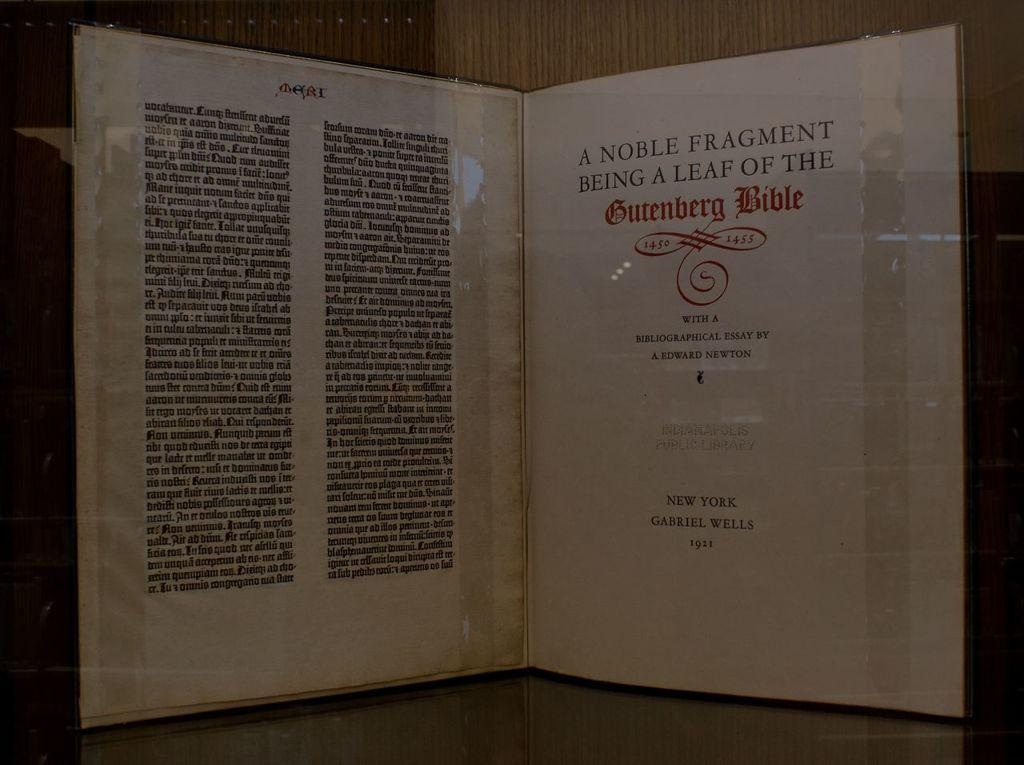<image>
Render a clear and concise summary of the photo. A book is displayed showing a page about the Gutenberg Bible. 